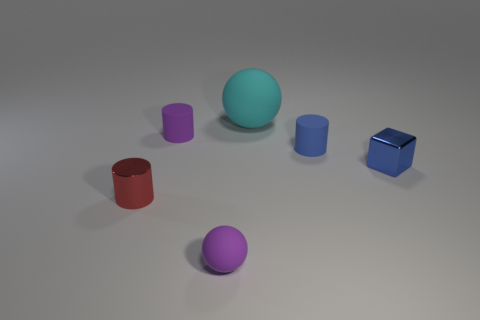Can you describe the lighting in the scene? The lighting in the scene is soft and diffuse, casting gentle shadows to the right of the objects, suggesting a light source from the top left out of frame. How might the lighting affect the appearance of the materials? The soft lighting helps to highlight the different material characteristics. For instance, it enhances the shininess of the reflective surfaces and the smooth texture of the matte sphere. 